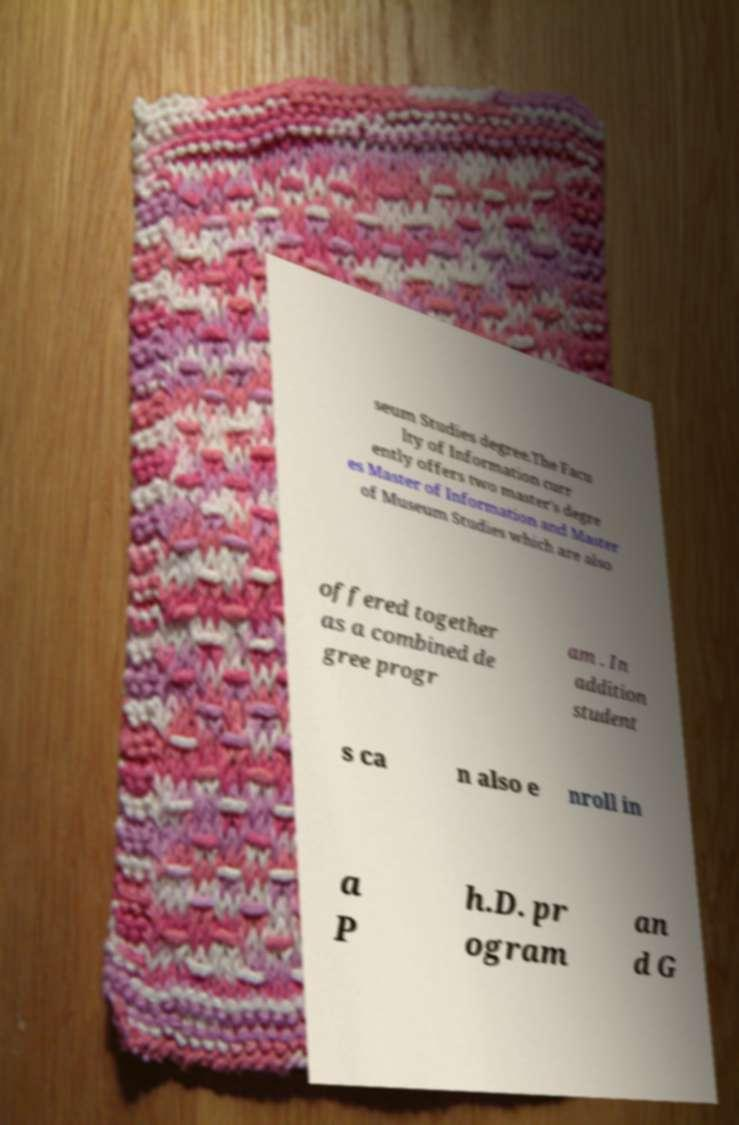Can you read and provide the text displayed in the image?This photo seems to have some interesting text. Can you extract and type it out for me? seum Studies degree.The Facu lty of Information curr ently offers two master's degre es Master of Information and Master of Museum Studies which are also offered together as a combined de gree progr am . In addition student s ca n also e nroll in a P h.D. pr ogram an d G 